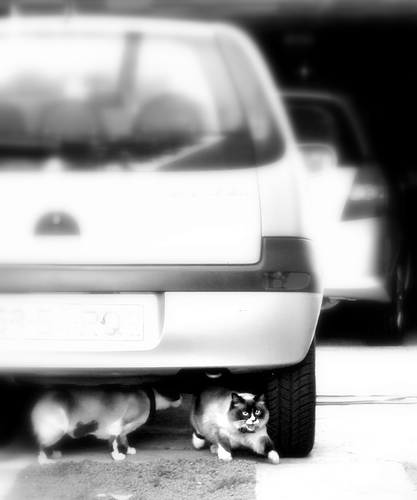<image>What is the license plate? The license plate is unknown. It is either not there, blank, or blurred. What is the license plate? I don't know the license plate. It is either not there, blank, blurry or blurred. 